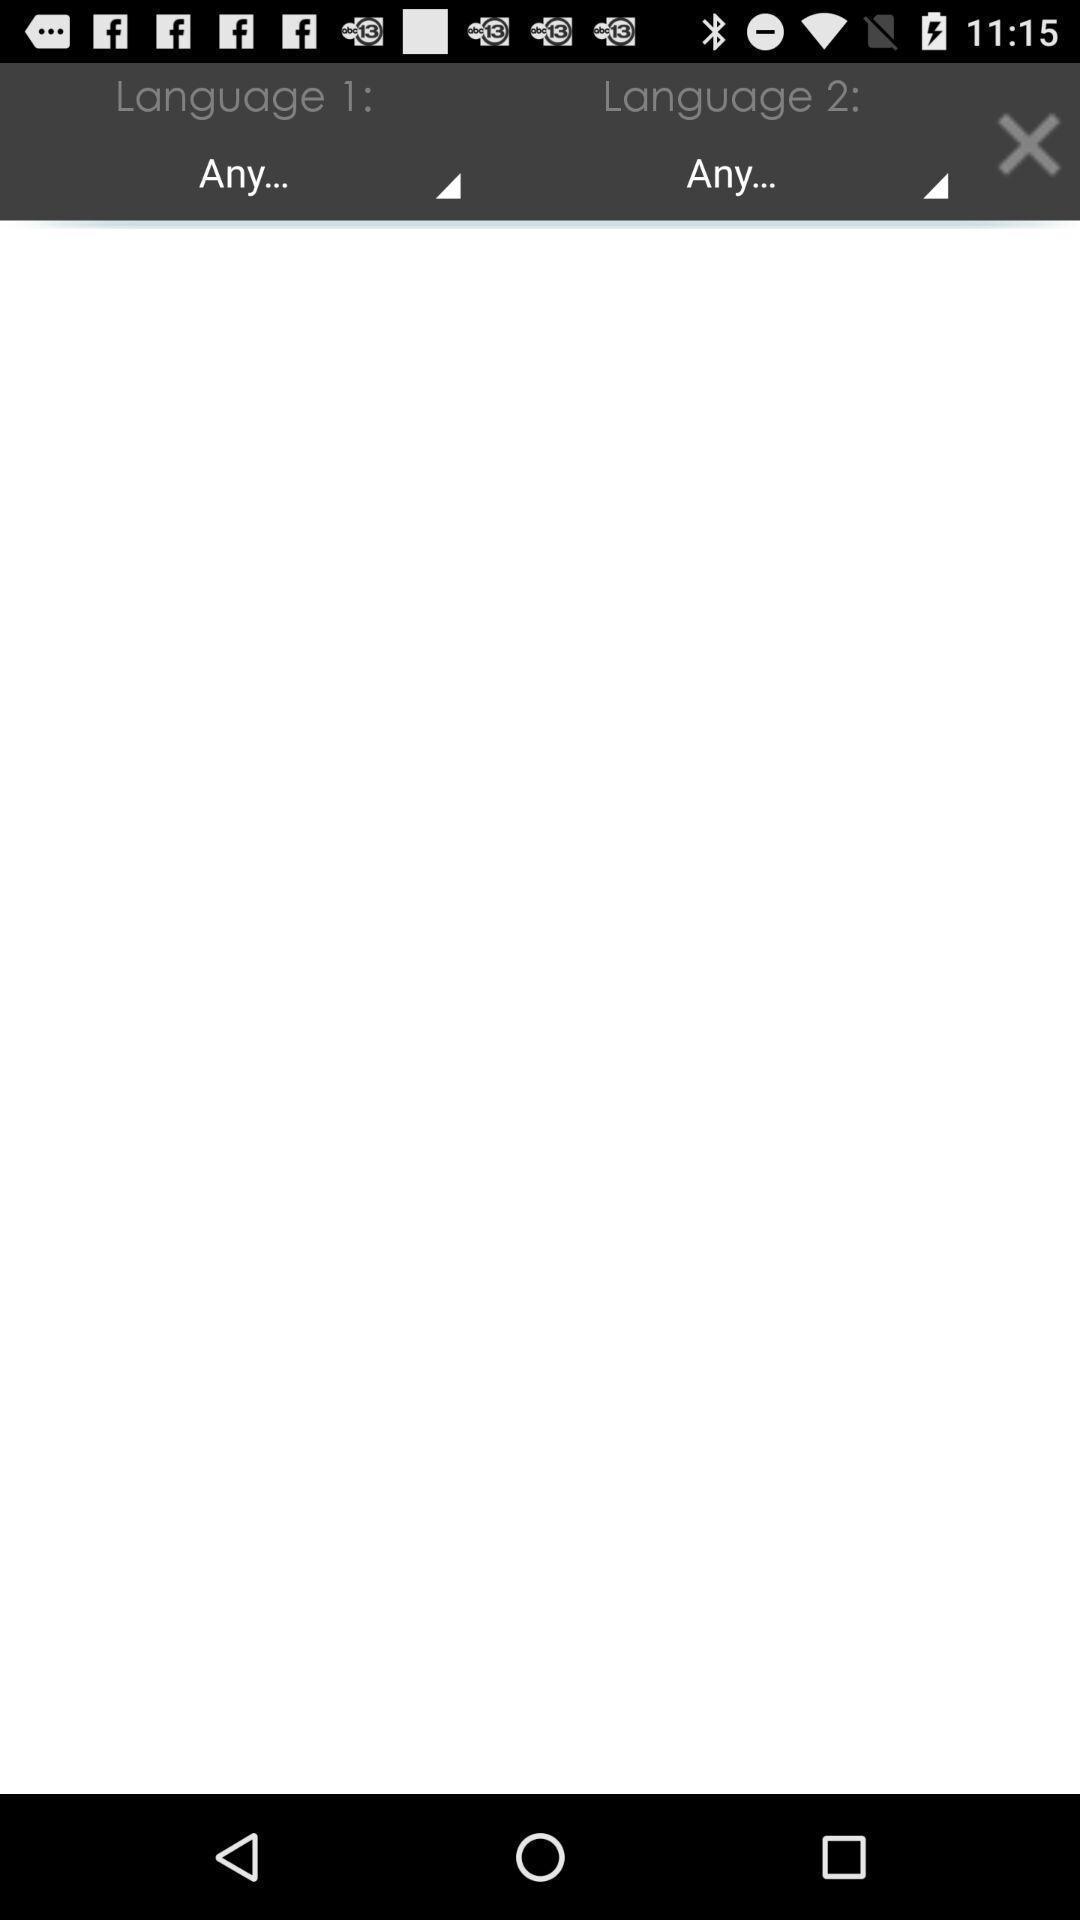Explain the elements present in this screenshot. Window displaying a translator app. 